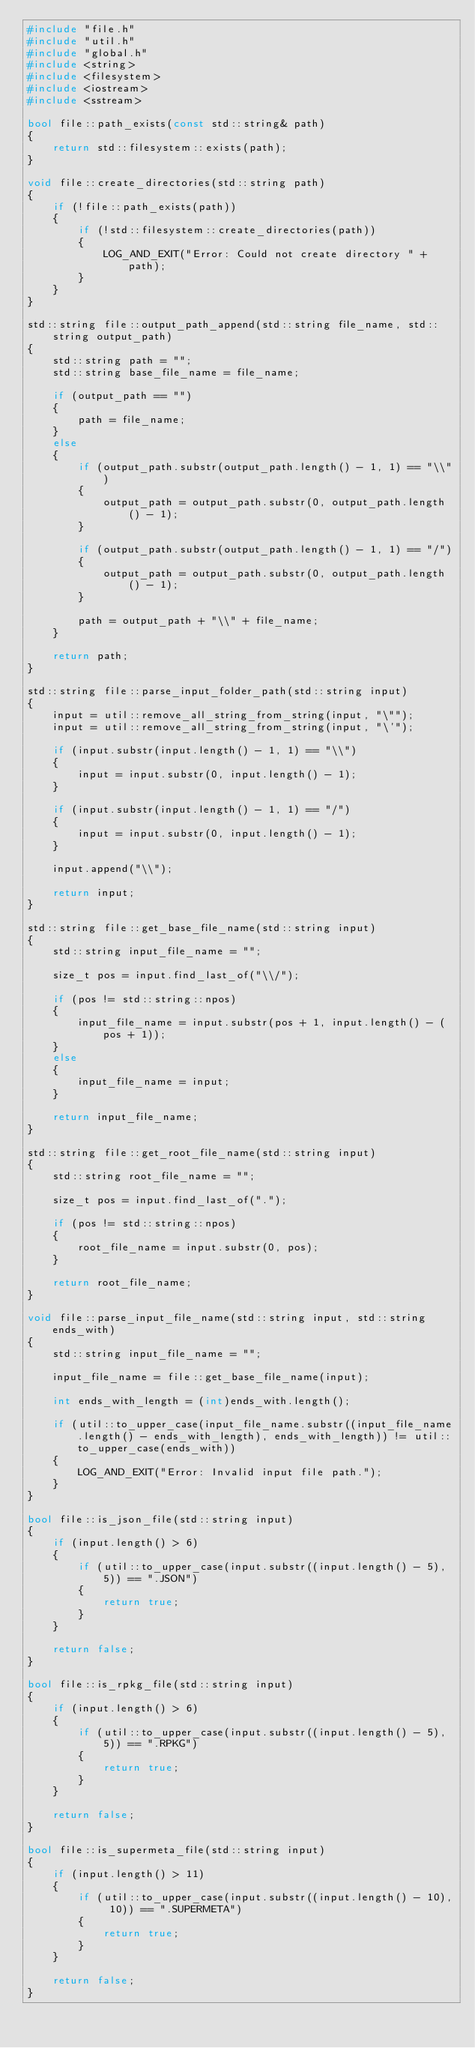Convert code to text. <code><loc_0><loc_0><loc_500><loc_500><_C++_>#include "file.h"
#include "util.h"
#include "global.h"
#include <string>
#include <filesystem>
#include <iostream>
#include <sstream>

bool file::path_exists(const std::string& path)
{
    return std::filesystem::exists(path);
}

void file::create_directories(std::string path)
{
    if (!file::path_exists(path))
    {
        if (!std::filesystem::create_directories(path))
        {
            LOG_AND_EXIT("Error: Could not create directory " + path);
        }
    }
}

std::string file::output_path_append(std::string file_name, std::string output_path)
{
    std::string path = "";
    std::string base_file_name = file_name;

    if (output_path == "")
    {
        path = file_name;
    }
    else
    {
        if (output_path.substr(output_path.length() - 1, 1) == "\\")
        {
            output_path = output_path.substr(0, output_path.length() - 1);
        }

        if (output_path.substr(output_path.length() - 1, 1) == "/")
        {
            output_path = output_path.substr(0, output_path.length() - 1);
        }

        path = output_path + "\\" + file_name;
    }

    return path;
}

std::string file::parse_input_folder_path(std::string input)
{
    input = util::remove_all_string_from_string(input, "\"");
    input = util::remove_all_string_from_string(input, "\'");

    if (input.substr(input.length() - 1, 1) == "\\")
    {
        input = input.substr(0, input.length() - 1);
    }

    if (input.substr(input.length() - 1, 1) == "/")
    {
        input = input.substr(0, input.length() - 1);
    }

    input.append("\\");

    return input;
}

std::string file::get_base_file_name(std::string input)
{
    std::string input_file_name = "";

    size_t pos = input.find_last_of("\\/");

    if (pos != std::string::npos)
    {
        input_file_name = input.substr(pos + 1, input.length() - (pos + 1));
    }
    else
    {
        input_file_name = input;
    }

    return input_file_name;
}

std::string file::get_root_file_name(std::string input)
{
    std::string root_file_name = "";

    size_t pos = input.find_last_of(".");

    if (pos != std::string::npos)
    {
        root_file_name = input.substr(0, pos);
    }

    return root_file_name;
}

void file::parse_input_file_name(std::string input, std::string ends_with)
{
    std::string input_file_name = "";

    input_file_name = file::get_base_file_name(input);

    int ends_with_length = (int)ends_with.length();

    if (util::to_upper_case(input_file_name.substr((input_file_name.length() - ends_with_length), ends_with_length)) != util::to_upper_case(ends_with))
    {
        LOG_AND_EXIT("Error: Invalid input file path.");
    }
}

bool file::is_json_file(std::string input)
{
    if (input.length() > 6)
    {
        if (util::to_upper_case(input.substr((input.length() - 5), 5)) == ".JSON")
        {
            return true;
        }
    }

    return false;
}

bool file::is_rpkg_file(std::string input)
{
    if (input.length() > 6)
    {
        if (util::to_upper_case(input.substr((input.length() - 5), 5)) == ".RPKG")
        {
            return true;
        }
    }

    return false;
}

bool file::is_supermeta_file(std::string input)
{
    if (input.length() > 11)
    {
        if (util::to_upper_case(input.substr((input.length() - 10), 10)) == ".SUPERMETA")
        {
            return true;
        }
    }

    return false;
}</code> 